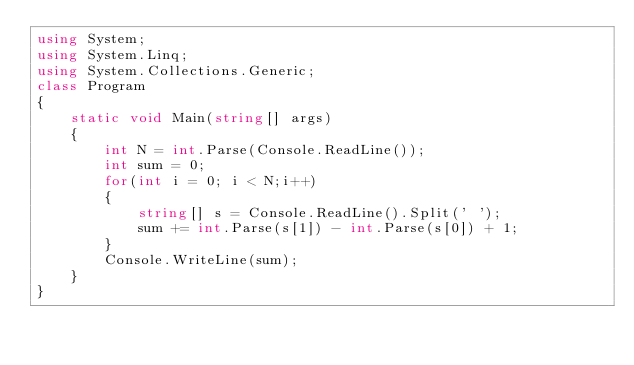<code> <loc_0><loc_0><loc_500><loc_500><_C#_>using System;
using System.Linq;
using System.Collections.Generic;
class Program
{
    static void Main(string[] args)
    {
        int N = int.Parse(Console.ReadLine());
        int sum = 0;
        for(int i = 0; i < N;i++)
        {
            string[] s = Console.ReadLine().Split(' ');
            sum += int.Parse(s[1]) - int.Parse(s[0]) + 1;
        }
        Console.WriteLine(sum);
    }
}
</code> 